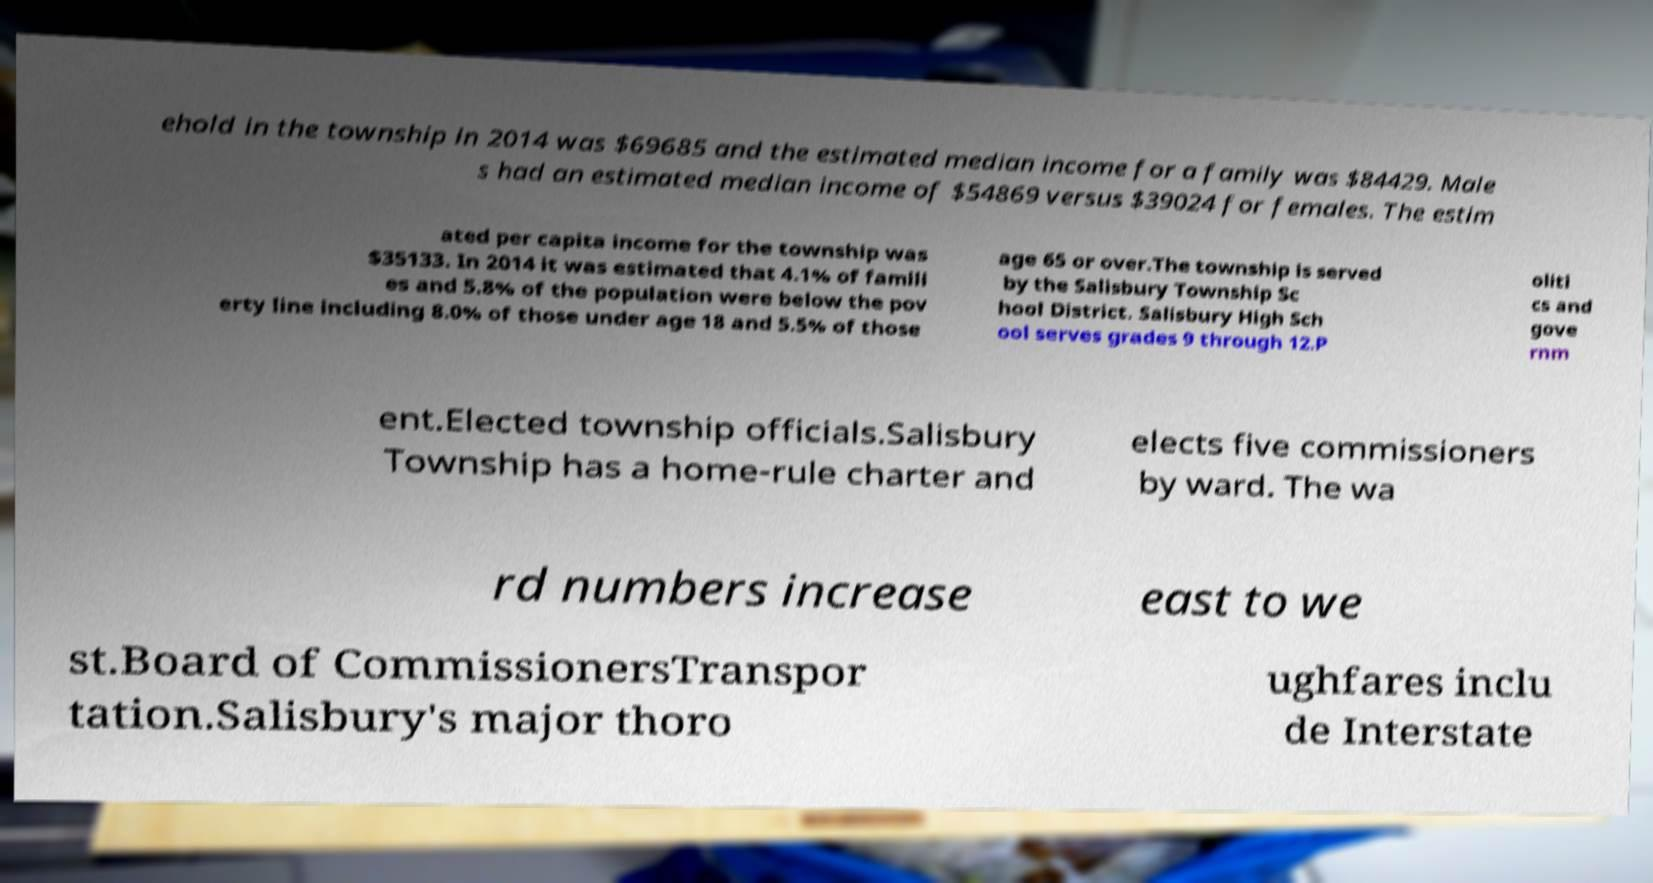There's text embedded in this image that I need extracted. Can you transcribe it verbatim? ehold in the township in 2014 was $69685 and the estimated median income for a family was $84429. Male s had an estimated median income of $54869 versus $39024 for females. The estim ated per capita income for the township was $35133. In 2014 it was estimated that 4.1% of famili es and 5.8% of the population were below the pov erty line including 8.0% of those under age 18 and 5.5% of those age 65 or over.The township is served by the Salisbury Township Sc hool District. Salisbury High Sch ool serves grades 9 through 12.P oliti cs and gove rnm ent.Elected township officials.Salisbury Township has a home-rule charter and elects five commissioners by ward. The wa rd numbers increase east to we st.Board of CommissionersTranspor tation.Salisbury's major thoro ughfares inclu de Interstate 